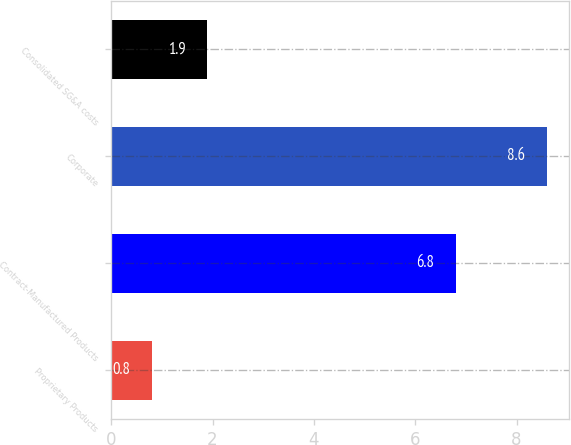Convert chart. <chart><loc_0><loc_0><loc_500><loc_500><bar_chart><fcel>Proprietary Products<fcel>Contract-Manufactured Products<fcel>Corporate<fcel>Consolidated SG&A costs<nl><fcel>0.8<fcel>6.8<fcel>8.6<fcel>1.9<nl></chart> 